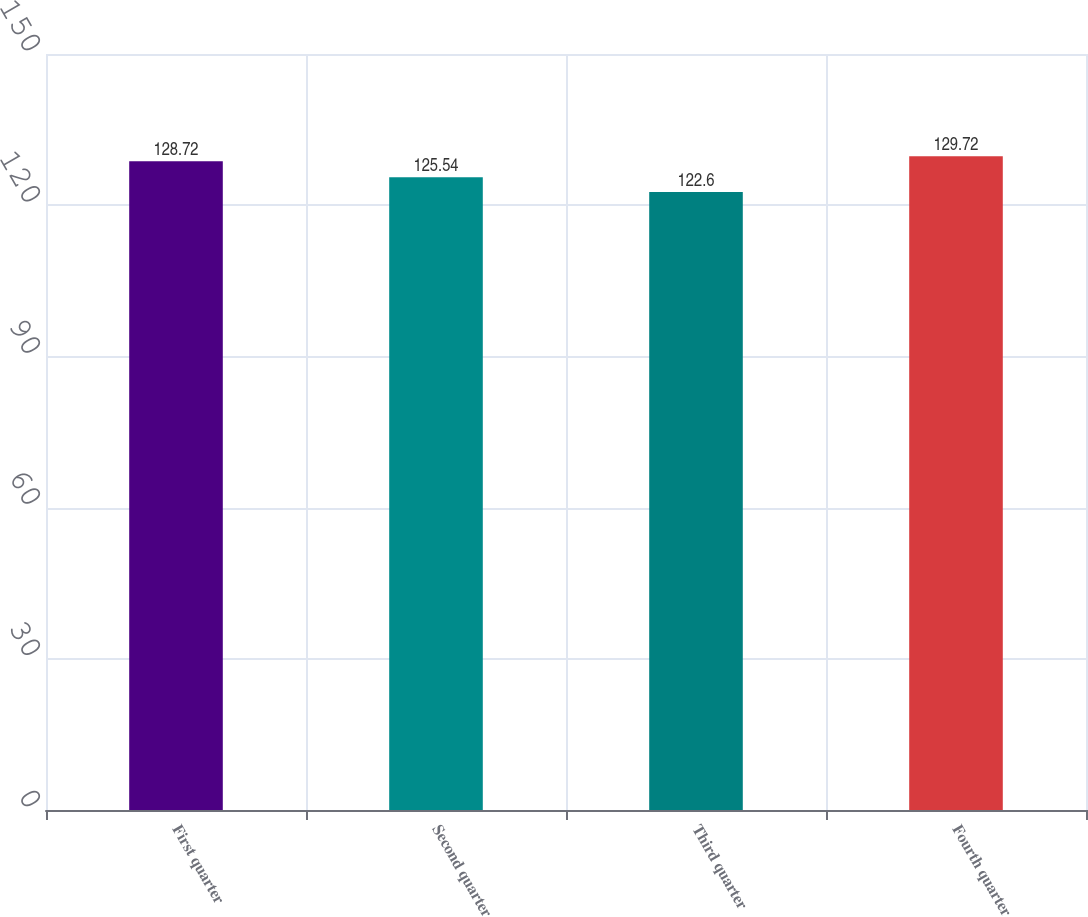Convert chart to OTSL. <chart><loc_0><loc_0><loc_500><loc_500><bar_chart><fcel>First quarter<fcel>Second quarter<fcel>Third quarter<fcel>Fourth quarter<nl><fcel>128.72<fcel>125.54<fcel>122.6<fcel>129.72<nl></chart> 